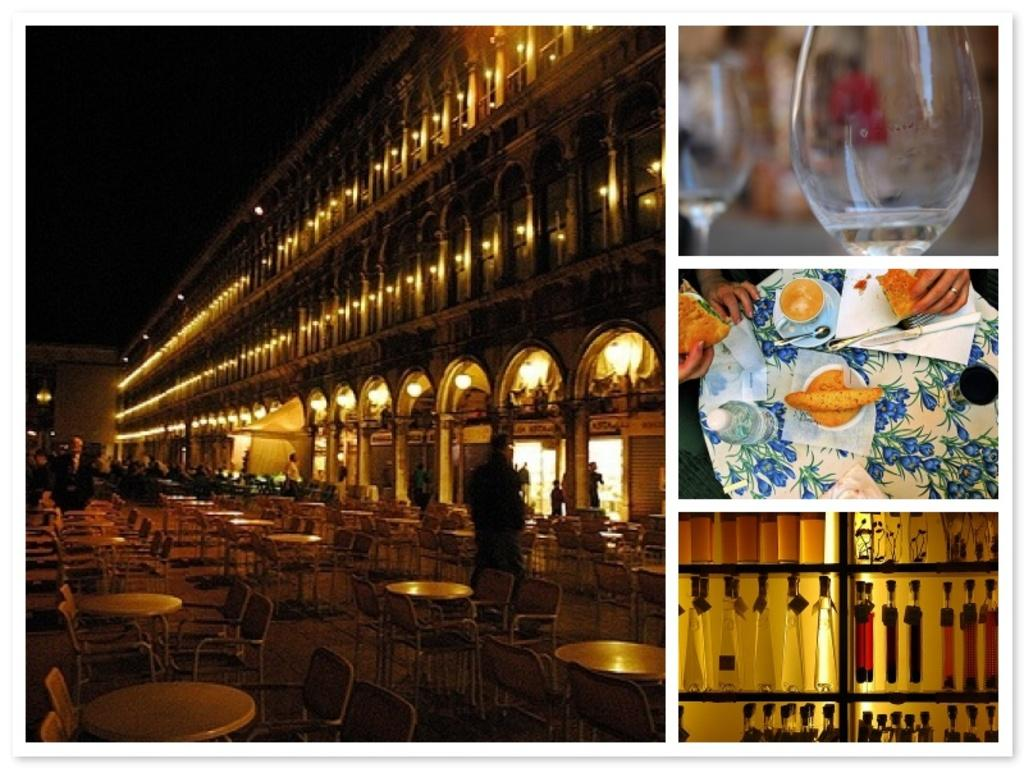What type of structure is visible in the image? There is a building in the image. What type of furniture is present in the image? There is a chair in the image. What type of tableware can be seen in the image? There are glasses and a plate in the image. What type of containers are visible in the image? There are bottles in the image. In which direction is the curve of the room facing in the image? There is no room or curve present in the image; it features a building, chair, glasses, plate, and bottles. 